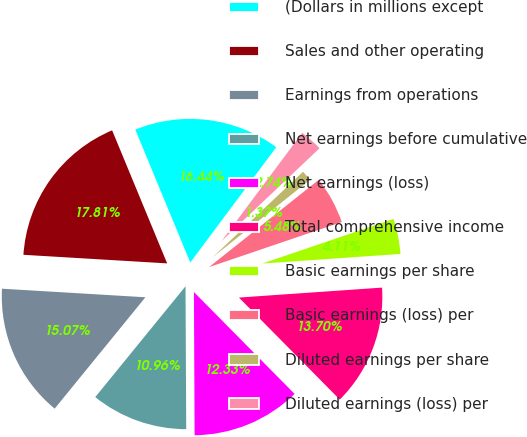Convert chart to OTSL. <chart><loc_0><loc_0><loc_500><loc_500><pie_chart><fcel>(Dollars in millions except<fcel>Sales and other operating<fcel>Earnings from operations<fcel>Net earnings before cumulative<fcel>Net earnings (loss)<fcel>Total comprehensive income<fcel>Basic earnings per share<fcel>Basic earnings (loss) per<fcel>Diluted earnings per share<fcel>Diluted earnings (loss) per<nl><fcel>16.44%<fcel>17.81%<fcel>15.07%<fcel>10.96%<fcel>12.33%<fcel>13.7%<fcel>4.11%<fcel>5.48%<fcel>1.37%<fcel>2.74%<nl></chart> 